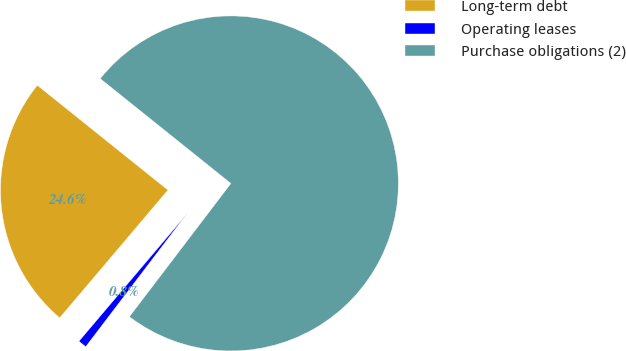Convert chart. <chart><loc_0><loc_0><loc_500><loc_500><pie_chart><fcel>Long-term debt<fcel>Operating leases<fcel>Purchase obligations (2)<nl><fcel>24.57%<fcel>0.83%<fcel>74.6%<nl></chart> 